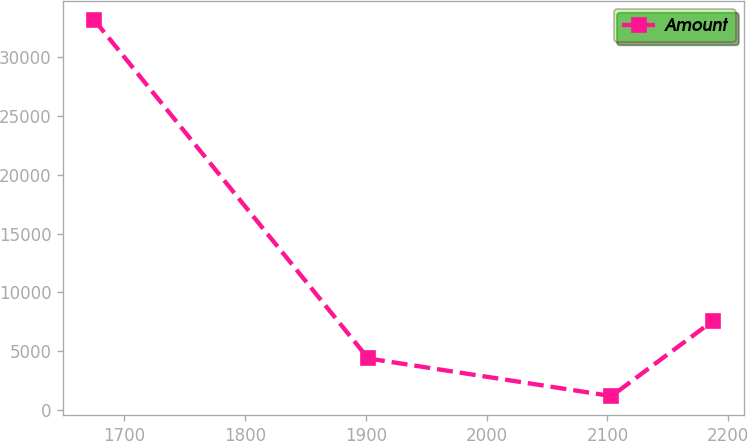Convert chart. <chart><loc_0><loc_0><loc_500><loc_500><line_chart><ecel><fcel>Amount<nl><fcel>1675.33<fcel>33143.2<nl><fcel>1902.07<fcel>4399.35<nl><fcel>2103.34<fcel>1205.58<nl><fcel>2187.28<fcel>7593.12<nl></chart> 